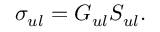Convert formula to latex. <formula><loc_0><loc_0><loc_500><loc_500>\sigma _ { u l } = G _ { u l } S _ { u l } .</formula> 